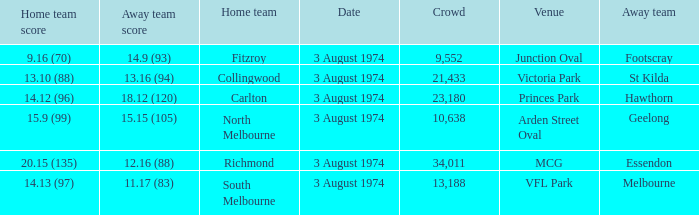Can you parse all the data within this table? {'header': ['Home team score', 'Away team score', 'Home team', 'Date', 'Crowd', 'Venue', 'Away team'], 'rows': [['9.16 (70)', '14.9 (93)', 'Fitzroy', '3 August 1974', '9,552', 'Junction Oval', 'Footscray'], ['13.10 (88)', '13.16 (94)', 'Collingwood', '3 August 1974', '21,433', 'Victoria Park', 'St Kilda'], ['14.12 (96)', '18.12 (120)', 'Carlton', '3 August 1974', '23,180', 'Princes Park', 'Hawthorn'], ['15.9 (99)', '15.15 (105)', 'North Melbourne', '3 August 1974', '10,638', 'Arden Street Oval', 'Geelong'], ['20.15 (135)', '12.16 (88)', 'Richmond', '3 August 1974', '34,011', 'MCG', 'Essendon'], ['14.13 (97)', '11.17 (83)', 'South Melbourne', '3 August 1974', '13,188', 'VFL Park', 'Melbourne']]} Which Venue has a Home team score of 9.16 (70)? Junction Oval. 